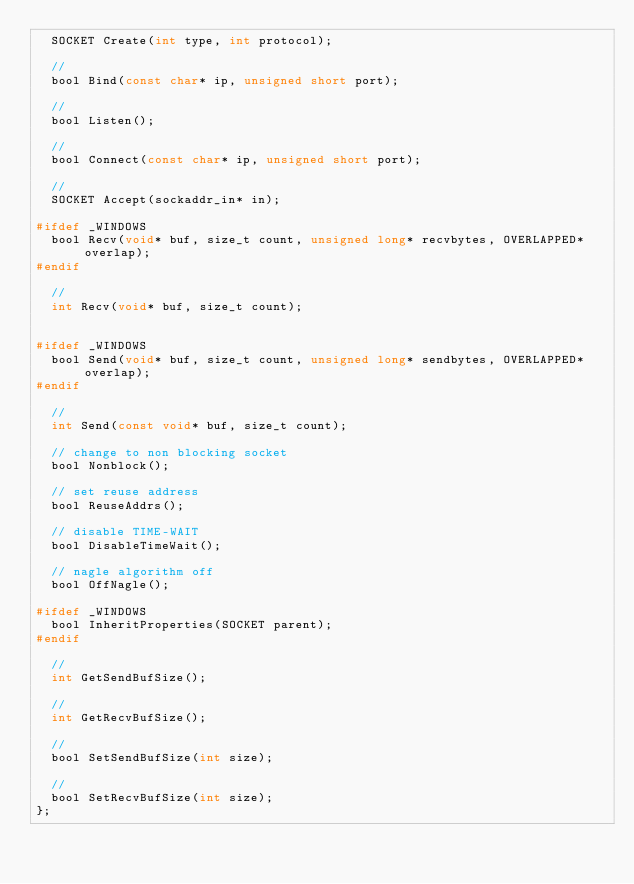Convert code to text. <code><loc_0><loc_0><loc_500><loc_500><_C_>	SOCKET Create(int type, int protocol);

	// 
	bool Bind(const char* ip, unsigned short port);

	//
	bool Listen();

	//
	bool Connect(const char* ip, unsigned short port);

	// 
	SOCKET Accept(sockaddr_in* in);

#ifdef _WINDOWS
	bool Recv(void* buf, size_t count, unsigned long* recvbytes, OVERLAPPED* overlap);
#endif

	//
	int Recv(void* buf, size_t count);


#ifdef _WINDOWS
	bool Send(void* buf, size_t count, unsigned long* sendbytes, OVERLAPPED* overlap);
#endif

	//
	int Send(const void* buf, size_t count);

	// change to non blocking socket
	bool Nonblock();

	// set reuse address 
	bool ReuseAddrs();

	// disable TIME-WAIT
	bool DisableTimeWait();

	// nagle algorithm off
	bool OffNagle();

#ifdef _WINDOWS
	bool InheritProperties(SOCKET parent);
#endif

	// 
	int GetSendBufSize();

	//
	int GetRecvBufSize();

	// 
	bool SetSendBufSize(int size);

	// 
	bool SetRecvBufSize(int size);
};

</code> 